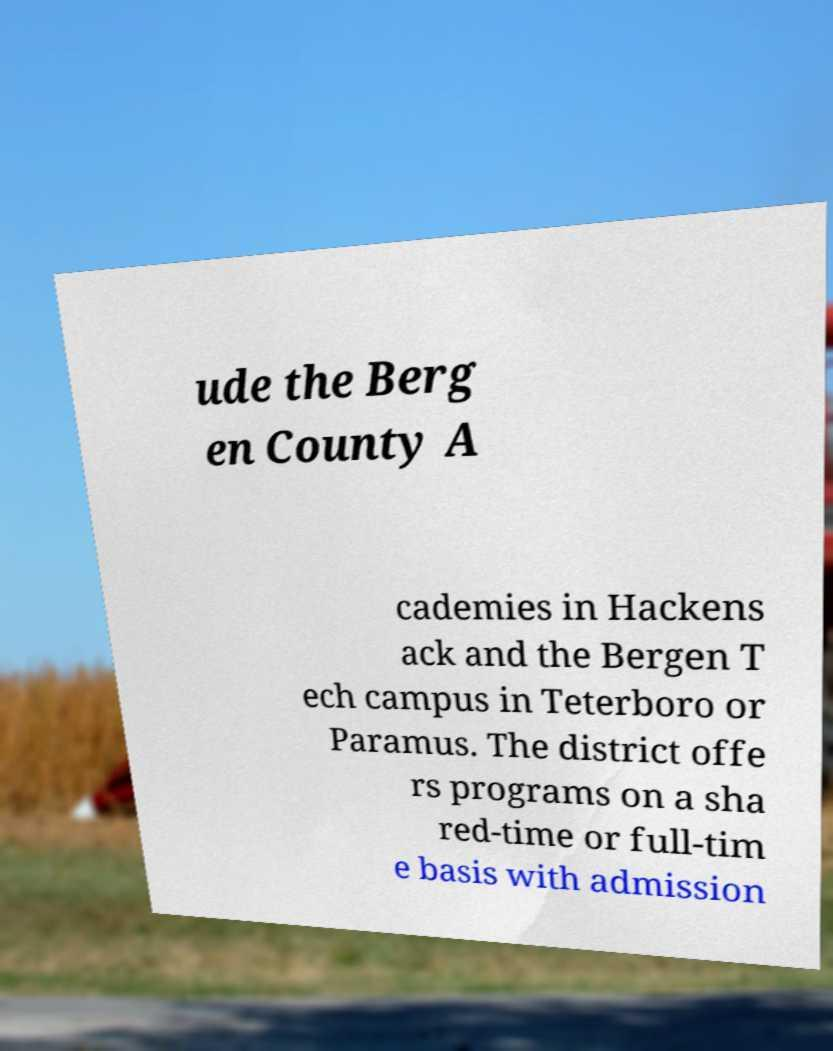Can you accurately transcribe the text from the provided image for me? ude the Berg en County A cademies in Hackens ack and the Bergen T ech campus in Teterboro or Paramus. The district offe rs programs on a sha red-time or full-tim e basis with admission 